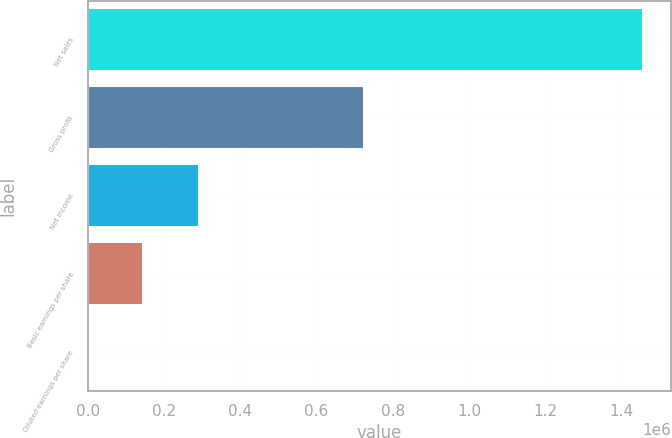Convert chart. <chart><loc_0><loc_0><loc_500><loc_500><bar_chart><fcel>Net sales<fcel>Gross profit<fcel>Net income<fcel>Basic earnings per share<fcel>Diluted earnings per share<nl><fcel>1.45753e+06<fcel>725350<fcel>291506<fcel>145754<fcel>1.21<nl></chart> 